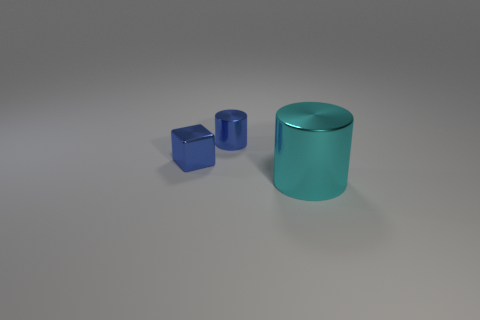Subtract all blue cylinders. Subtract all purple blocks. How many cylinders are left? 1 Subtract all red cylinders. How many red blocks are left? 0 Add 2 things. How many large cyans exist? 0 Subtract all big blue things. Subtract all small objects. How many objects are left? 1 Add 2 small cubes. How many small cubes are left? 3 Add 2 small cylinders. How many small cylinders exist? 3 Add 1 blue metal objects. How many objects exist? 4 Subtract all blue cylinders. How many cylinders are left? 1 Subtract 1 blue cubes. How many objects are left? 2 Subtract all blocks. How many objects are left? 2 